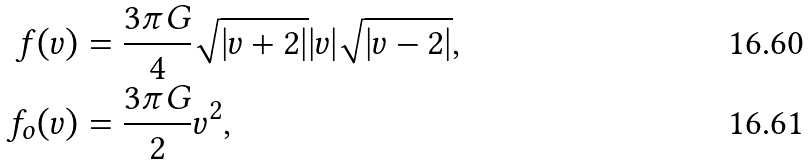<formula> <loc_0><loc_0><loc_500><loc_500>f ( v ) & = \frac { 3 \pi G } { 4 } \sqrt { | v + 2 | } | v | \sqrt { | v - 2 | } , \\ f _ { o } ( v ) & = \frac { 3 \pi G } { 2 } v ^ { 2 } ,</formula> 